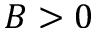<formula> <loc_0><loc_0><loc_500><loc_500>B > 0</formula> 